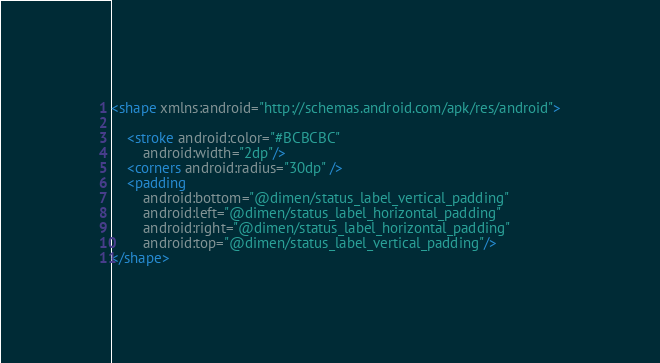Convert code to text. <code><loc_0><loc_0><loc_500><loc_500><_XML_><shape xmlns:android="http://schemas.android.com/apk/res/android">

    <stroke android:color="#BCBCBC"
        android:width="2dp"/>
    <corners android:radius="30dp" />
    <padding
        android:bottom="@dimen/status_label_vertical_padding"
        android:left="@dimen/status_label_horizontal_padding"
        android:right="@dimen/status_label_horizontal_padding"
        android:top="@dimen/status_label_vertical_padding"/>
</shape>
</code> 